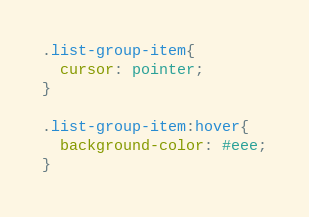<code> <loc_0><loc_0><loc_500><loc_500><_CSS_>
.list-group-item{
  cursor: pointer;
}

.list-group-item:hover{
  background-color: #eee;
}
</code> 